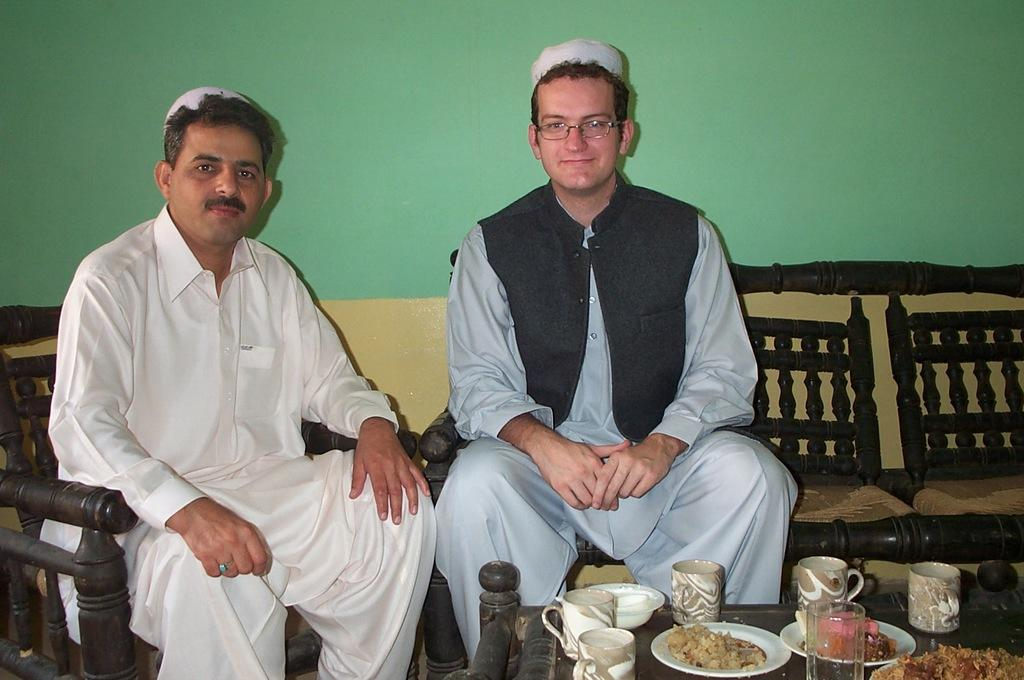How many people are sitting in the image? There are two men sitting in the image. What type of furniture is present in the image? There is a chair and a sofa in the image. What can be found on the table in the image? There are cups, plates, a glass, food, and a bowl on the table. What is visible in the background of the image? There is a wall in the background of the image. What type of zipper can be seen on the behavior of the men in the image? There is no zipper present in the image, and the behavior of the men cannot be determined from the image alone. 